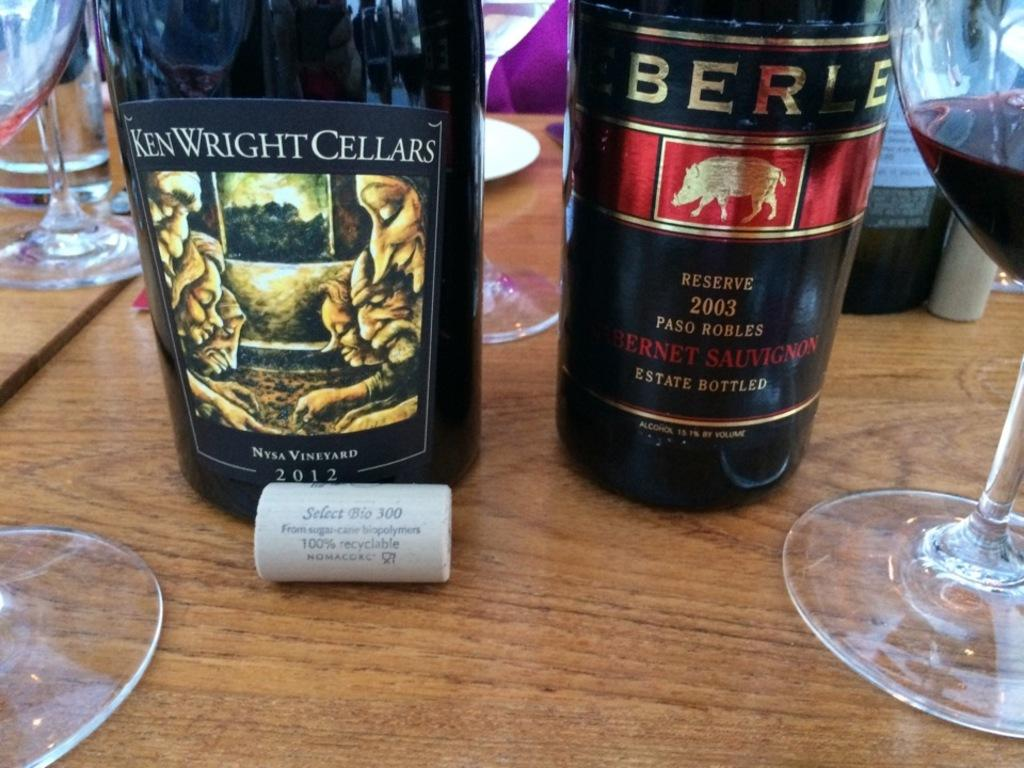<image>
Relay a brief, clear account of the picture shown. A bottle of Ken Wright Cellars is sitting on the table. 